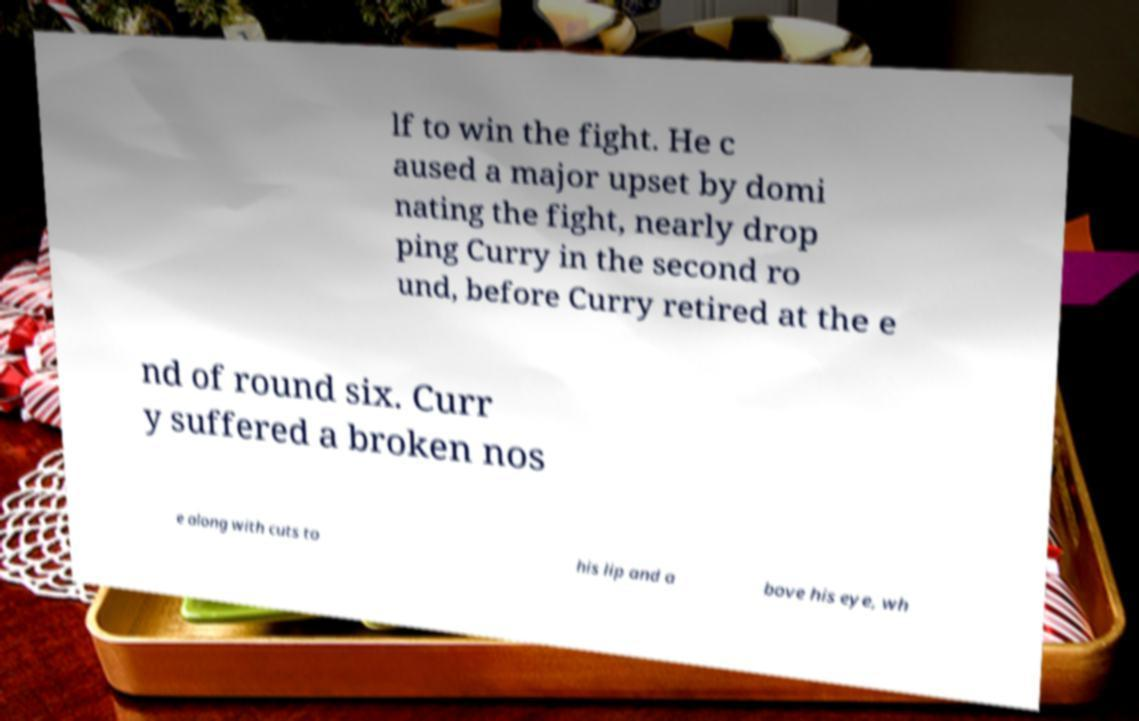Could you extract and type out the text from this image? lf to win the fight. He c aused a major upset by domi nating the fight, nearly drop ping Curry in the second ro und, before Curry retired at the e nd of round six. Curr y suffered a broken nos e along with cuts to his lip and a bove his eye, wh 